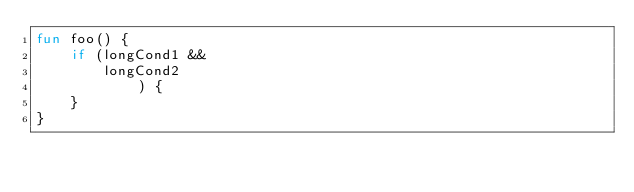Convert code to text. <code><loc_0><loc_0><loc_500><loc_500><_Kotlin_>fun foo() {
    if (longCond1 &&
        longCond2
            ) {
    }
}
</code> 